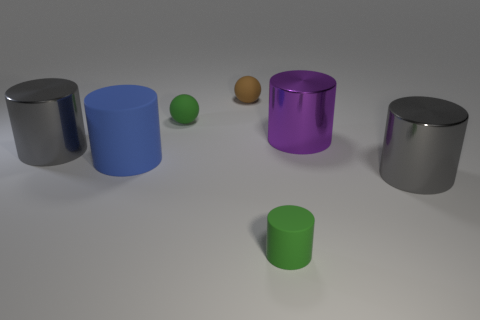There is a purple cylinder that is behind the blue cylinder; are there any gray metallic cylinders that are behind it?
Provide a short and direct response. No. Are there an equal number of big things that are right of the large purple thing and small rubber spheres that are behind the small brown matte object?
Your response must be concise. No. What is the color of the large cylinder that is made of the same material as the small green cylinder?
Provide a succinct answer. Blue. Are there any big cylinders that have the same material as the small green ball?
Your response must be concise. Yes. What number of objects are either green shiny cylinders or big blue things?
Offer a terse response. 1. Is the tiny green sphere made of the same material as the big gray cylinder to the left of the tiny green cylinder?
Provide a short and direct response. No. What is the size of the shiny object left of the brown sphere?
Keep it short and to the point. Large. Are there fewer large gray metal cylinders than large blue cylinders?
Offer a very short reply. No. Is there a small metal cylinder that has the same color as the large matte object?
Your answer should be very brief. No. There is a matte thing that is in front of the purple cylinder and to the left of the small brown thing; what is its shape?
Provide a short and direct response. Cylinder. 